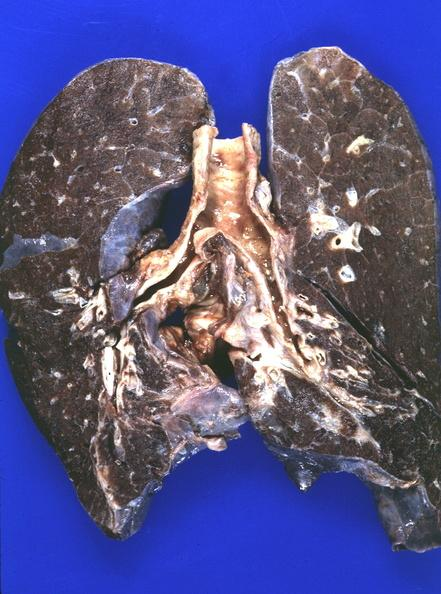does autoimmune thyroiditis show lung, iron overload?
Answer the question using a single word or phrase. No 